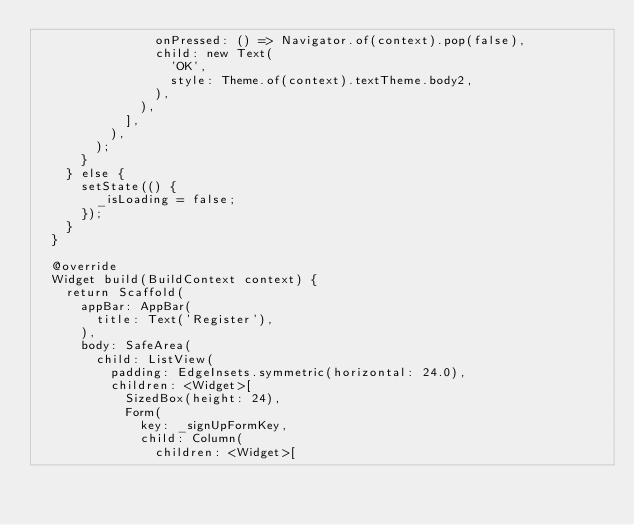Convert code to text. <code><loc_0><loc_0><loc_500><loc_500><_Dart_>                onPressed: () => Navigator.of(context).pop(false),
                child: new Text(
                  'OK',
                  style: Theme.of(context).textTheme.body2,
                ),
              ),
            ],
          ),
        );
      }
    } else {
      setState(() {
        _isLoading = false;
      });
    }
  }

  @override
  Widget build(BuildContext context) {
    return Scaffold(
      appBar: AppBar(
        title: Text('Register'),
      ),
      body: SafeArea(
        child: ListView(
          padding: EdgeInsets.symmetric(horizontal: 24.0),
          children: <Widget>[
            SizedBox(height: 24),
            Form(
              key: _signUpFormKey,
              child: Column(
                children: <Widget>[</code> 